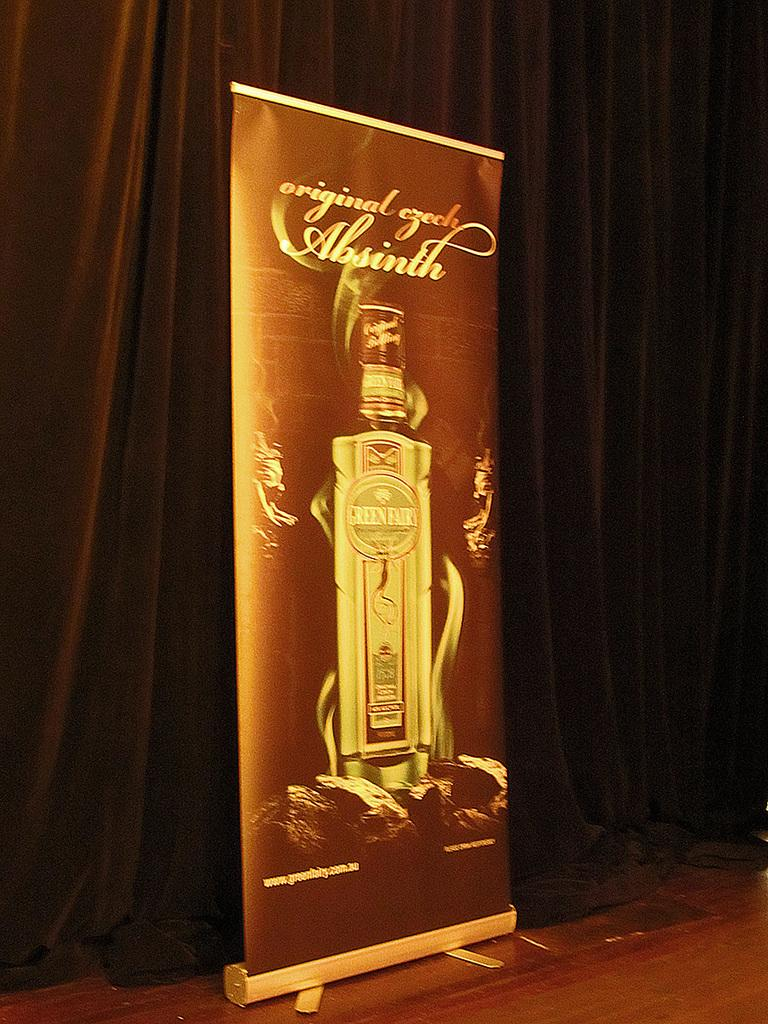<image>
Provide a brief description of the given image. A large promotional poster for Absinth stands in front of a brown curtain. 